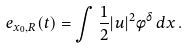Convert formula to latex. <formula><loc_0><loc_0><loc_500><loc_500>e _ { x _ { 0 } , R } ( t ) = \int \frac { 1 } { 2 } | u | ^ { 2 } \phi ^ { \delta } \, d x \, .</formula> 